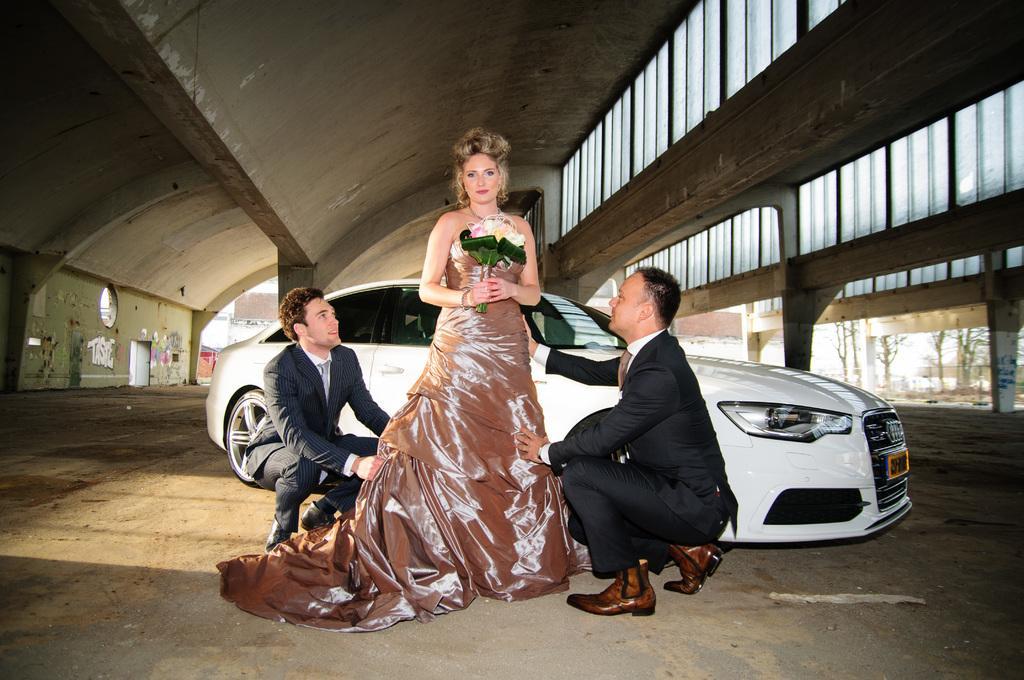In one or two sentences, can you explain what this image depicts? In the center of the image, we can see a lady holding a bouquet and there are some people wearing coats and ties. In the background, we can see a car on the road and we can see trees and buildings and there are posters on the wall and there is some text. At the top, there is a roof. 